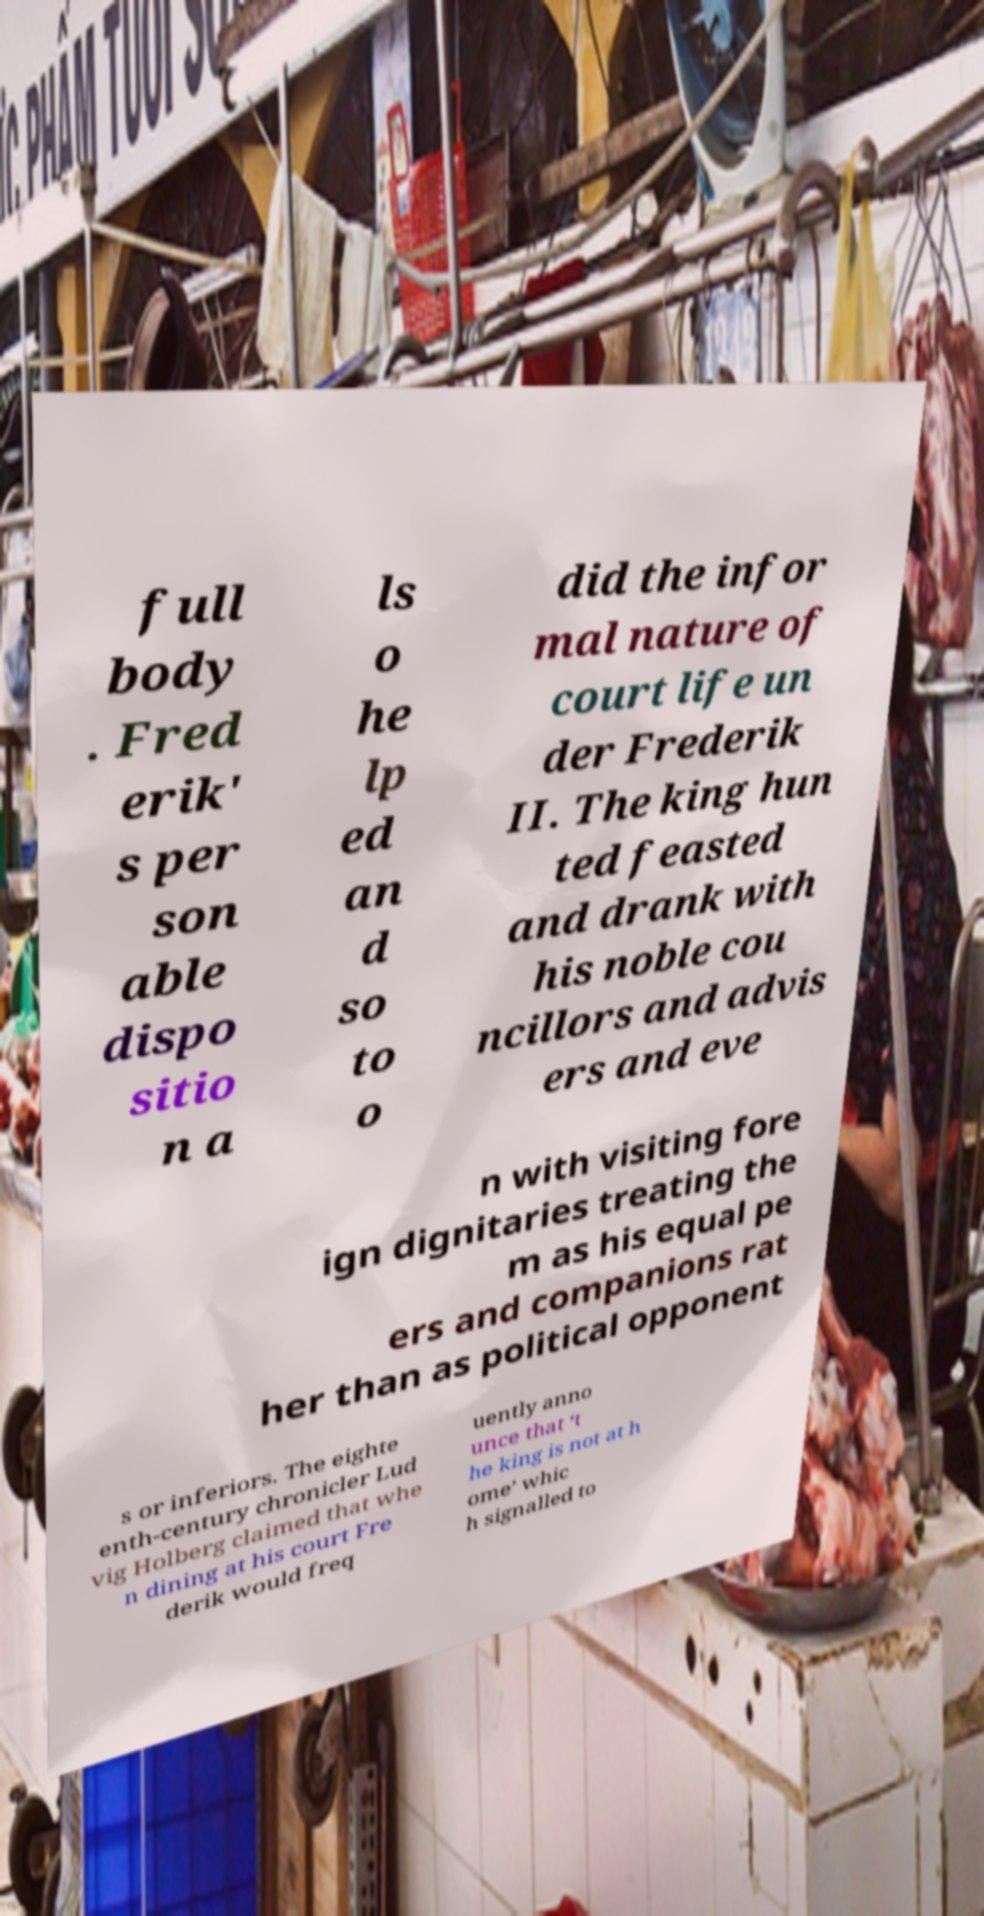Can you read and provide the text displayed in the image?This photo seems to have some interesting text. Can you extract and type it out for me? full body . Fred erik' s per son able dispo sitio n a ls o he lp ed an d so to o did the infor mal nature of court life un der Frederik II. The king hun ted feasted and drank with his noble cou ncillors and advis ers and eve n with visiting fore ign dignitaries treating the m as his equal pe ers and companions rat her than as political opponent s or inferiors. The eighte enth-century chronicler Lud vig Holberg claimed that whe n dining at his court Fre derik would freq uently anno unce that ‘t he king is not at h ome’ whic h signalled to 